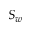<formula> <loc_0><loc_0><loc_500><loc_500>S _ { w }</formula> 